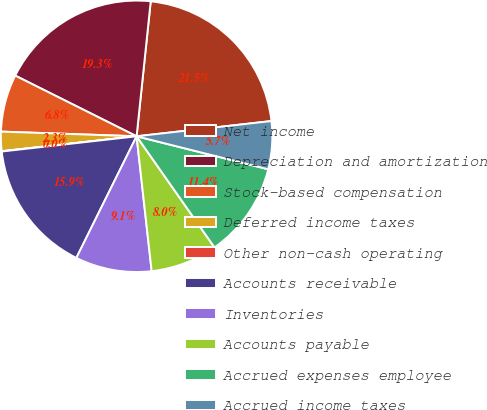Convert chart to OTSL. <chart><loc_0><loc_0><loc_500><loc_500><pie_chart><fcel>Net income<fcel>Depreciation and amortization<fcel>Stock-based compensation<fcel>Deferred income taxes<fcel>Other non-cash operating<fcel>Accounts receivable<fcel>Inventories<fcel>Accounts payable<fcel>Accrued expenses employee<fcel>Accrued income taxes<nl><fcel>21.55%<fcel>19.28%<fcel>6.83%<fcel>2.3%<fcel>0.04%<fcel>15.89%<fcel>9.09%<fcel>7.96%<fcel>11.36%<fcel>5.7%<nl></chart> 